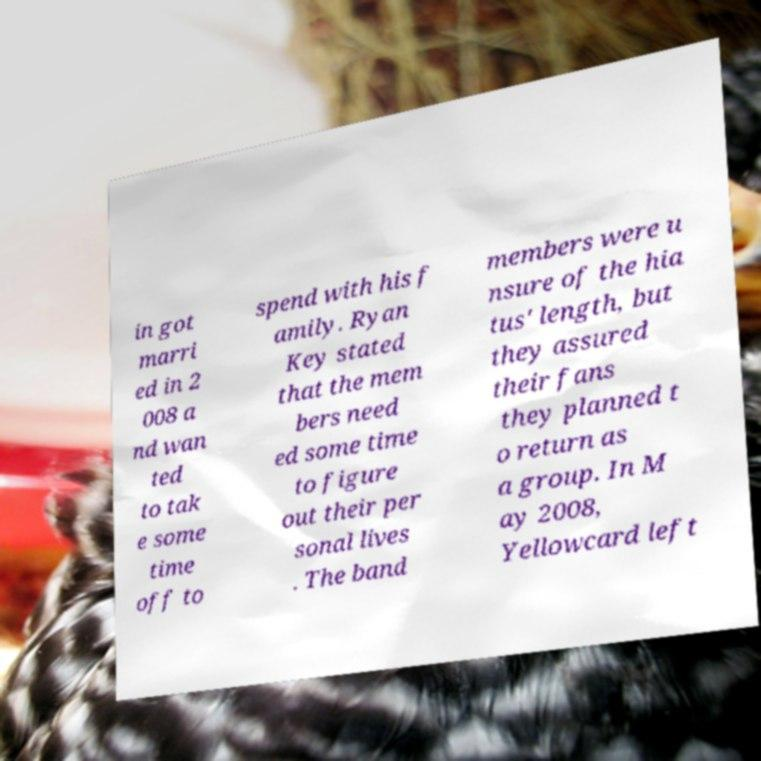Please read and relay the text visible in this image. What does it say? in got marri ed in 2 008 a nd wan ted to tak e some time off to spend with his f amily. Ryan Key stated that the mem bers need ed some time to figure out their per sonal lives . The band members were u nsure of the hia tus' length, but they assured their fans they planned t o return as a group. In M ay 2008, Yellowcard left 